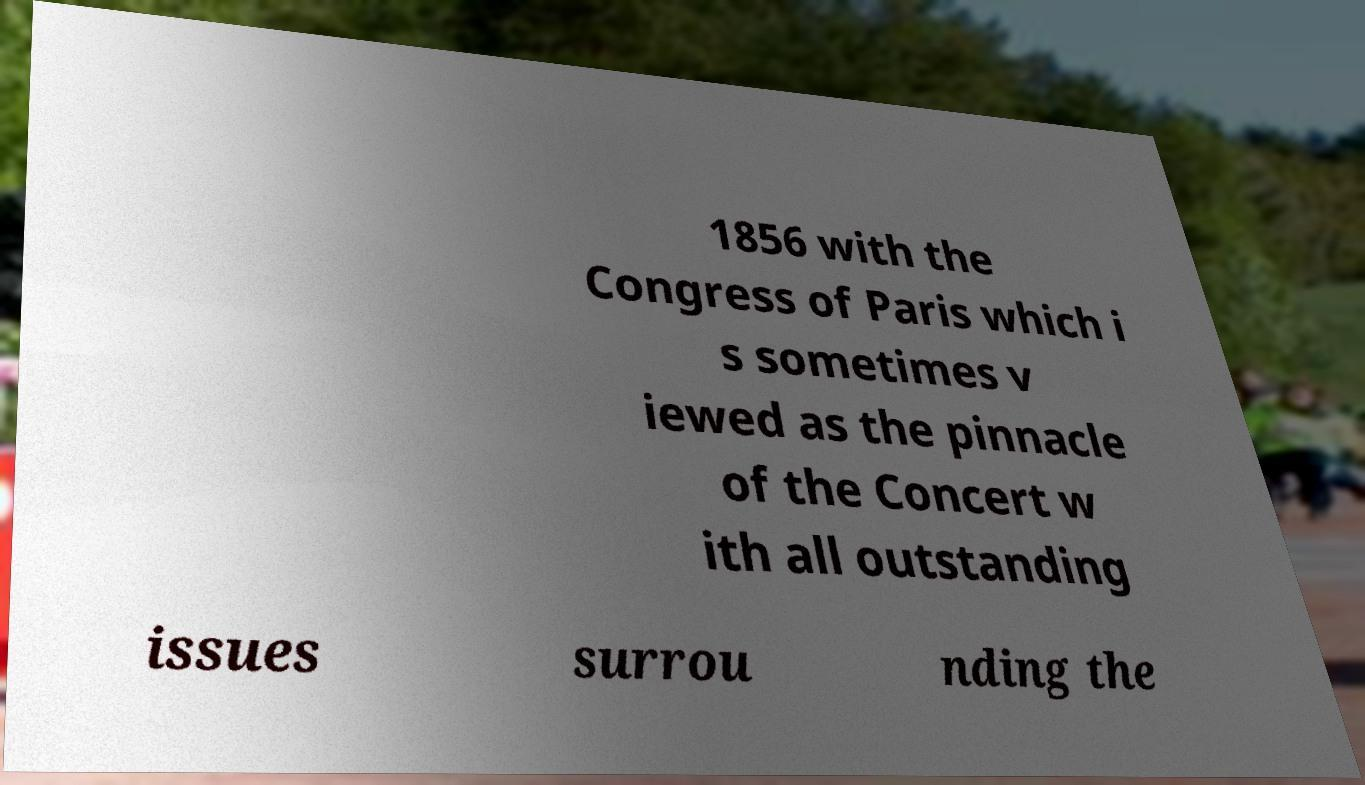Can you accurately transcribe the text from the provided image for me? 1856 with the Congress of Paris which i s sometimes v iewed as the pinnacle of the Concert w ith all outstanding issues surrou nding the 